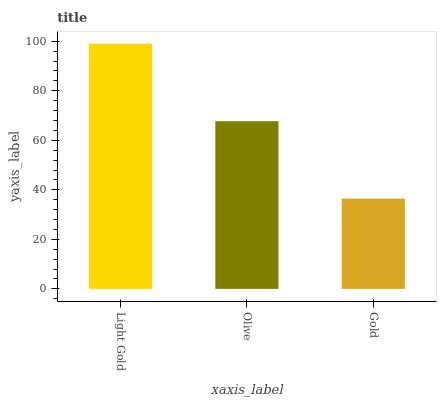Is Gold the minimum?
Answer yes or no. Yes. Is Light Gold the maximum?
Answer yes or no. Yes. Is Olive the minimum?
Answer yes or no. No. Is Olive the maximum?
Answer yes or no. No. Is Light Gold greater than Olive?
Answer yes or no. Yes. Is Olive less than Light Gold?
Answer yes or no. Yes. Is Olive greater than Light Gold?
Answer yes or no. No. Is Light Gold less than Olive?
Answer yes or no. No. Is Olive the high median?
Answer yes or no. Yes. Is Olive the low median?
Answer yes or no. Yes. Is Gold the high median?
Answer yes or no. No. Is Light Gold the low median?
Answer yes or no. No. 